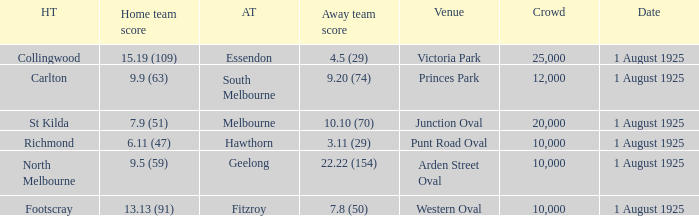Which match where Hawthorn was the away team had the largest crowd? 10000.0. Help me parse the entirety of this table. {'header': ['HT', 'Home team score', 'AT', 'Away team score', 'Venue', 'Crowd', 'Date'], 'rows': [['Collingwood', '15.19 (109)', 'Essendon', '4.5 (29)', 'Victoria Park', '25,000', '1 August 1925'], ['Carlton', '9.9 (63)', 'South Melbourne', '9.20 (74)', 'Princes Park', '12,000', '1 August 1925'], ['St Kilda', '7.9 (51)', 'Melbourne', '10.10 (70)', 'Junction Oval', '20,000', '1 August 1925'], ['Richmond', '6.11 (47)', 'Hawthorn', '3.11 (29)', 'Punt Road Oval', '10,000', '1 August 1925'], ['North Melbourne', '9.5 (59)', 'Geelong', '22.22 (154)', 'Arden Street Oval', '10,000', '1 August 1925'], ['Footscray', '13.13 (91)', 'Fitzroy', '7.8 (50)', 'Western Oval', '10,000', '1 August 1925']]} 